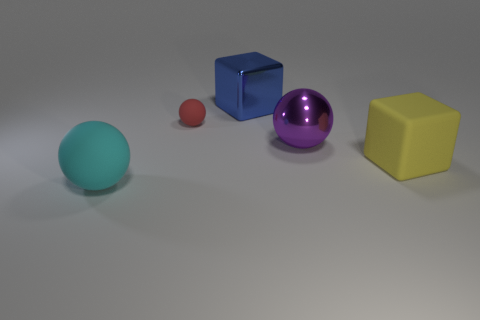Add 2 big purple spheres. How many objects exist? 7 Subtract all balls. How many objects are left? 2 Add 3 tiny red matte objects. How many tiny red matte objects exist? 4 Subtract 0 green cubes. How many objects are left? 5 Subtract all large red matte spheres. Subtract all small matte balls. How many objects are left? 4 Add 5 red matte objects. How many red matte objects are left? 6 